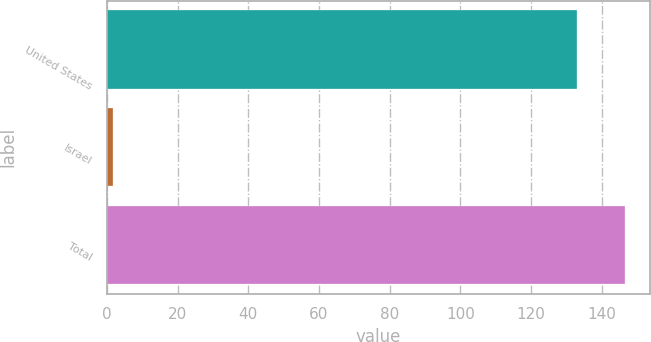Convert chart. <chart><loc_0><loc_0><loc_500><loc_500><bar_chart><fcel>United States<fcel>Israel<fcel>Total<nl><fcel>132.9<fcel>1.8<fcel>146.45<nl></chart> 